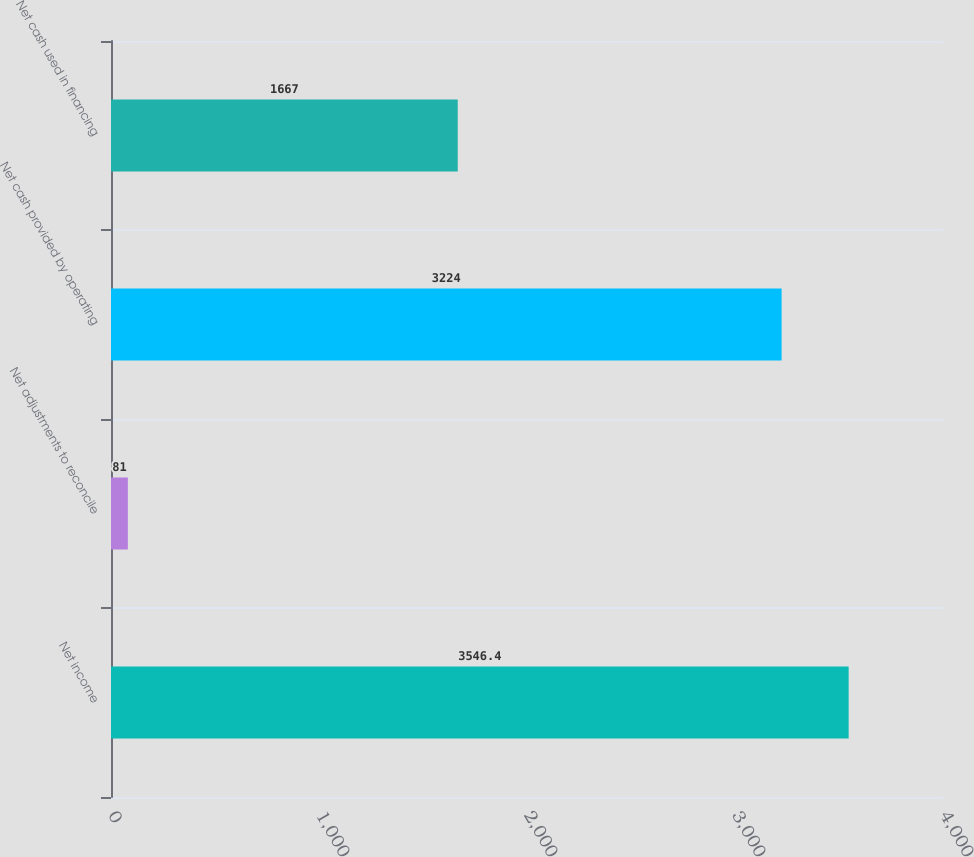<chart> <loc_0><loc_0><loc_500><loc_500><bar_chart><fcel>Net income<fcel>Net adjustments to reconcile<fcel>Net cash provided by operating<fcel>Net cash used in financing<nl><fcel>3546.4<fcel>81<fcel>3224<fcel>1667<nl></chart> 